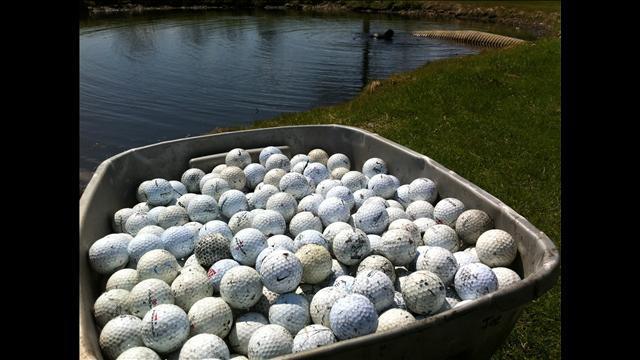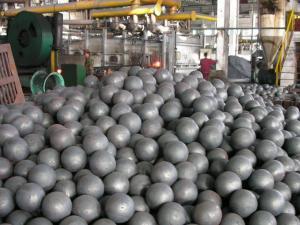The first image is the image on the left, the second image is the image on the right. Considering the images on both sides, is "An image shows many golf balls piled into a squarish tub container." valid? Answer yes or no. Yes. The first image is the image on the left, the second image is the image on the right. For the images shown, is this caption "Some of the balls are sitting in tubs." true? Answer yes or no. Yes. 